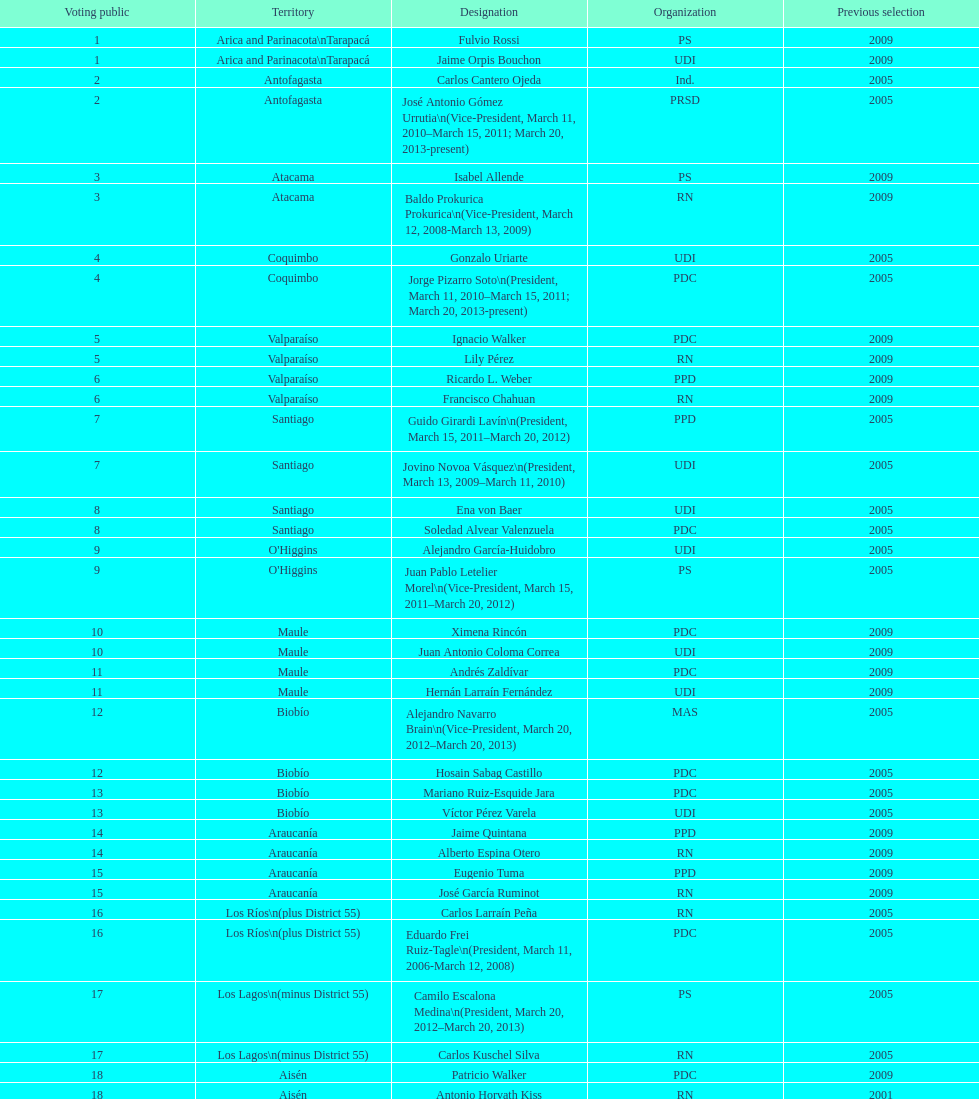Who was not last elected in either 2005 or 2009? Antonio Horvath Kiss. 